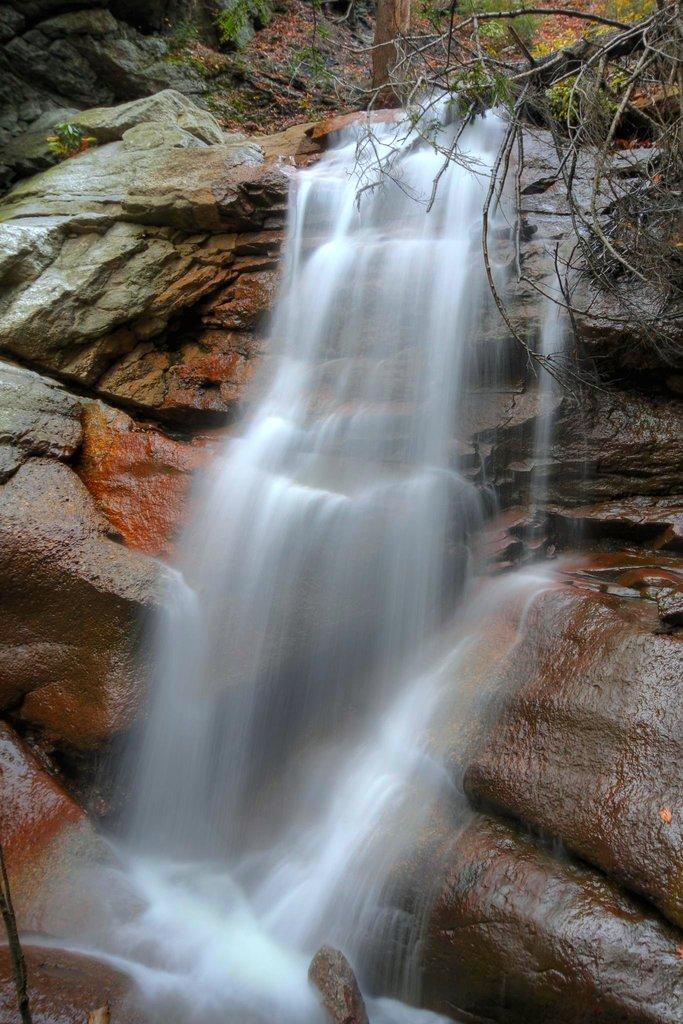What natural feature is the main subject of the image? There is a waterfall in the image. What can be seen in the distance behind the waterfall? There are hills and trees in the background of the image. Where is the bead located in the image? There is no bead present in the image. What is the aftermath of the waterfall in the image? The provided facts do not mention any aftermath of the waterfall; the image only shows the waterfall itself. 